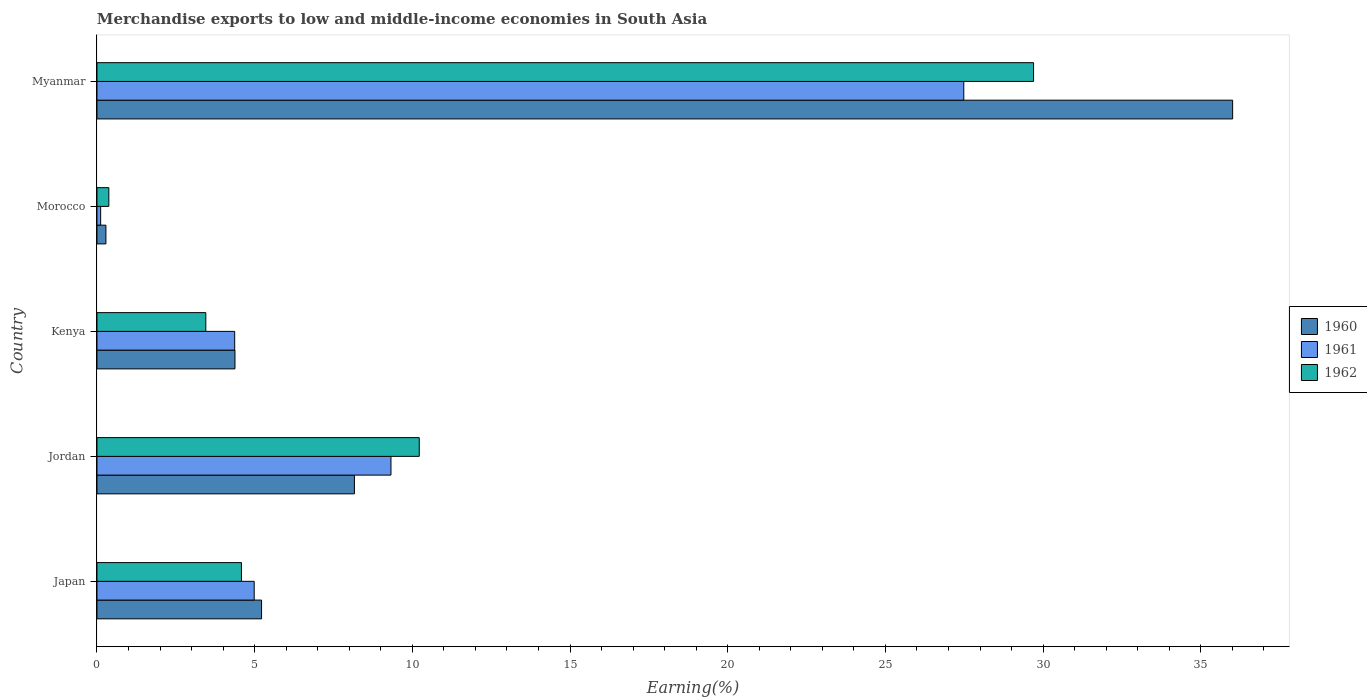How many different coloured bars are there?
Offer a very short reply. 3. How many groups of bars are there?
Ensure brevity in your answer.  5. Are the number of bars per tick equal to the number of legend labels?
Ensure brevity in your answer.  Yes. Are the number of bars on each tick of the Y-axis equal?
Your answer should be compact. Yes. How many bars are there on the 4th tick from the top?
Offer a terse response. 3. What is the label of the 3rd group of bars from the top?
Offer a terse response. Kenya. In how many cases, is the number of bars for a given country not equal to the number of legend labels?
Your answer should be compact. 0. What is the percentage of amount earned from merchandise exports in 1961 in Kenya?
Ensure brevity in your answer.  4.37. Across all countries, what is the maximum percentage of amount earned from merchandise exports in 1961?
Offer a very short reply. 27.48. Across all countries, what is the minimum percentage of amount earned from merchandise exports in 1961?
Give a very brief answer. 0.12. In which country was the percentage of amount earned from merchandise exports in 1962 maximum?
Provide a succinct answer. Myanmar. In which country was the percentage of amount earned from merchandise exports in 1962 minimum?
Provide a succinct answer. Morocco. What is the total percentage of amount earned from merchandise exports in 1960 in the graph?
Keep it short and to the point. 54.05. What is the difference between the percentage of amount earned from merchandise exports in 1962 in Jordan and that in Morocco?
Make the answer very short. 9.84. What is the difference between the percentage of amount earned from merchandise exports in 1962 in Jordan and the percentage of amount earned from merchandise exports in 1961 in Japan?
Your answer should be compact. 5.23. What is the average percentage of amount earned from merchandise exports in 1962 per country?
Offer a very short reply. 9.66. What is the difference between the percentage of amount earned from merchandise exports in 1961 and percentage of amount earned from merchandise exports in 1962 in Japan?
Provide a short and direct response. 0.4. What is the ratio of the percentage of amount earned from merchandise exports in 1962 in Japan to that in Morocco?
Keep it short and to the point. 12.17. Is the percentage of amount earned from merchandise exports in 1962 in Japan less than that in Myanmar?
Offer a terse response. Yes. Is the difference between the percentage of amount earned from merchandise exports in 1961 in Jordan and Myanmar greater than the difference between the percentage of amount earned from merchandise exports in 1962 in Jordan and Myanmar?
Your answer should be very brief. Yes. What is the difference between the highest and the second highest percentage of amount earned from merchandise exports in 1960?
Make the answer very short. 27.85. What is the difference between the highest and the lowest percentage of amount earned from merchandise exports in 1962?
Offer a terse response. 29.32. How many bars are there?
Give a very brief answer. 15. What is the difference between two consecutive major ticks on the X-axis?
Your response must be concise. 5. Does the graph contain grids?
Ensure brevity in your answer.  No. How many legend labels are there?
Ensure brevity in your answer.  3. How are the legend labels stacked?
Ensure brevity in your answer.  Vertical. What is the title of the graph?
Your response must be concise. Merchandise exports to low and middle-income economies in South Asia. What is the label or title of the X-axis?
Keep it short and to the point. Earning(%). What is the label or title of the Y-axis?
Your response must be concise. Country. What is the Earning(%) of 1960 in Japan?
Your answer should be compact. 5.22. What is the Earning(%) in 1961 in Japan?
Provide a short and direct response. 4.99. What is the Earning(%) of 1962 in Japan?
Make the answer very short. 4.58. What is the Earning(%) in 1960 in Jordan?
Offer a very short reply. 8.16. What is the Earning(%) of 1961 in Jordan?
Offer a very short reply. 9.32. What is the Earning(%) of 1962 in Jordan?
Ensure brevity in your answer.  10.22. What is the Earning(%) of 1960 in Kenya?
Offer a terse response. 4.38. What is the Earning(%) in 1961 in Kenya?
Keep it short and to the point. 4.37. What is the Earning(%) of 1962 in Kenya?
Your answer should be compact. 3.45. What is the Earning(%) in 1960 in Morocco?
Provide a short and direct response. 0.28. What is the Earning(%) in 1961 in Morocco?
Offer a very short reply. 0.12. What is the Earning(%) in 1962 in Morocco?
Your answer should be compact. 0.38. What is the Earning(%) of 1960 in Myanmar?
Ensure brevity in your answer.  36.01. What is the Earning(%) of 1961 in Myanmar?
Give a very brief answer. 27.48. What is the Earning(%) in 1962 in Myanmar?
Provide a short and direct response. 29.7. Across all countries, what is the maximum Earning(%) in 1960?
Provide a short and direct response. 36.01. Across all countries, what is the maximum Earning(%) of 1961?
Your answer should be compact. 27.48. Across all countries, what is the maximum Earning(%) in 1962?
Make the answer very short. 29.7. Across all countries, what is the minimum Earning(%) in 1960?
Offer a very short reply. 0.28. Across all countries, what is the minimum Earning(%) in 1961?
Your answer should be compact. 0.12. Across all countries, what is the minimum Earning(%) of 1962?
Offer a very short reply. 0.38. What is the total Earning(%) in 1960 in the graph?
Offer a terse response. 54.05. What is the total Earning(%) in 1961 in the graph?
Your response must be concise. 46.28. What is the total Earning(%) in 1962 in the graph?
Make the answer very short. 48.32. What is the difference between the Earning(%) of 1960 in Japan and that in Jordan?
Your answer should be compact. -2.94. What is the difference between the Earning(%) in 1961 in Japan and that in Jordan?
Offer a terse response. -4.34. What is the difference between the Earning(%) of 1962 in Japan and that in Jordan?
Offer a very short reply. -5.64. What is the difference between the Earning(%) of 1960 in Japan and that in Kenya?
Your response must be concise. 0.84. What is the difference between the Earning(%) of 1961 in Japan and that in Kenya?
Your response must be concise. 0.62. What is the difference between the Earning(%) of 1962 in Japan and that in Kenya?
Keep it short and to the point. 1.13. What is the difference between the Earning(%) of 1960 in Japan and that in Morocco?
Provide a short and direct response. 4.93. What is the difference between the Earning(%) of 1961 in Japan and that in Morocco?
Your answer should be very brief. 4.87. What is the difference between the Earning(%) of 1962 in Japan and that in Morocco?
Your answer should be compact. 4.2. What is the difference between the Earning(%) in 1960 in Japan and that in Myanmar?
Your answer should be very brief. -30.79. What is the difference between the Earning(%) of 1961 in Japan and that in Myanmar?
Ensure brevity in your answer.  -22.5. What is the difference between the Earning(%) of 1962 in Japan and that in Myanmar?
Your answer should be compact. -25.12. What is the difference between the Earning(%) of 1960 in Jordan and that in Kenya?
Your response must be concise. 3.79. What is the difference between the Earning(%) in 1961 in Jordan and that in Kenya?
Provide a succinct answer. 4.96. What is the difference between the Earning(%) in 1962 in Jordan and that in Kenya?
Your answer should be compact. 6.77. What is the difference between the Earning(%) of 1960 in Jordan and that in Morocco?
Offer a terse response. 7.88. What is the difference between the Earning(%) in 1961 in Jordan and that in Morocco?
Ensure brevity in your answer.  9.21. What is the difference between the Earning(%) of 1962 in Jordan and that in Morocco?
Your answer should be very brief. 9.84. What is the difference between the Earning(%) in 1960 in Jordan and that in Myanmar?
Offer a very short reply. -27.85. What is the difference between the Earning(%) of 1961 in Jordan and that in Myanmar?
Offer a terse response. -18.16. What is the difference between the Earning(%) in 1962 in Jordan and that in Myanmar?
Give a very brief answer. -19.48. What is the difference between the Earning(%) in 1960 in Kenya and that in Morocco?
Offer a very short reply. 4.09. What is the difference between the Earning(%) in 1961 in Kenya and that in Morocco?
Provide a short and direct response. 4.25. What is the difference between the Earning(%) in 1962 in Kenya and that in Morocco?
Your answer should be very brief. 3.07. What is the difference between the Earning(%) of 1960 in Kenya and that in Myanmar?
Your response must be concise. -31.63. What is the difference between the Earning(%) in 1961 in Kenya and that in Myanmar?
Offer a terse response. -23.12. What is the difference between the Earning(%) of 1962 in Kenya and that in Myanmar?
Provide a short and direct response. -26.25. What is the difference between the Earning(%) of 1960 in Morocco and that in Myanmar?
Ensure brevity in your answer.  -35.73. What is the difference between the Earning(%) of 1961 in Morocco and that in Myanmar?
Your response must be concise. -27.37. What is the difference between the Earning(%) in 1962 in Morocco and that in Myanmar?
Provide a succinct answer. -29.32. What is the difference between the Earning(%) in 1960 in Japan and the Earning(%) in 1961 in Jordan?
Keep it short and to the point. -4.1. What is the difference between the Earning(%) of 1960 in Japan and the Earning(%) of 1962 in Jordan?
Offer a very short reply. -5. What is the difference between the Earning(%) in 1961 in Japan and the Earning(%) in 1962 in Jordan?
Ensure brevity in your answer.  -5.23. What is the difference between the Earning(%) in 1960 in Japan and the Earning(%) in 1961 in Kenya?
Give a very brief answer. 0.85. What is the difference between the Earning(%) in 1960 in Japan and the Earning(%) in 1962 in Kenya?
Your answer should be very brief. 1.77. What is the difference between the Earning(%) of 1961 in Japan and the Earning(%) of 1962 in Kenya?
Offer a very short reply. 1.53. What is the difference between the Earning(%) in 1960 in Japan and the Earning(%) in 1961 in Morocco?
Give a very brief answer. 5.1. What is the difference between the Earning(%) in 1960 in Japan and the Earning(%) in 1962 in Morocco?
Keep it short and to the point. 4.84. What is the difference between the Earning(%) of 1961 in Japan and the Earning(%) of 1962 in Morocco?
Ensure brevity in your answer.  4.61. What is the difference between the Earning(%) in 1960 in Japan and the Earning(%) in 1961 in Myanmar?
Provide a succinct answer. -22.27. What is the difference between the Earning(%) of 1960 in Japan and the Earning(%) of 1962 in Myanmar?
Ensure brevity in your answer.  -24.48. What is the difference between the Earning(%) in 1961 in Japan and the Earning(%) in 1962 in Myanmar?
Keep it short and to the point. -24.71. What is the difference between the Earning(%) of 1960 in Jordan and the Earning(%) of 1961 in Kenya?
Offer a very short reply. 3.8. What is the difference between the Earning(%) of 1960 in Jordan and the Earning(%) of 1962 in Kenya?
Give a very brief answer. 4.71. What is the difference between the Earning(%) of 1961 in Jordan and the Earning(%) of 1962 in Kenya?
Your answer should be compact. 5.87. What is the difference between the Earning(%) in 1960 in Jordan and the Earning(%) in 1961 in Morocco?
Make the answer very short. 8.05. What is the difference between the Earning(%) of 1960 in Jordan and the Earning(%) of 1962 in Morocco?
Give a very brief answer. 7.79. What is the difference between the Earning(%) of 1961 in Jordan and the Earning(%) of 1962 in Morocco?
Your response must be concise. 8.95. What is the difference between the Earning(%) in 1960 in Jordan and the Earning(%) in 1961 in Myanmar?
Provide a succinct answer. -19.32. What is the difference between the Earning(%) of 1960 in Jordan and the Earning(%) of 1962 in Myanmar?
Provide a succinct answer. -21.53. What is the difference between the Earning(%) in 1961 in Jordan and the Earning(%) in 1962 in Myanmar?
Make the answer very short. -20.38. What is the difference between the Earning(%) in 1960 in Kenya and the Earning(%) in 1961 in Morocco?
Provide a succinct answer. 4.26. What is the difference between the Earning(%) in 1960 in Kenya and the Earning(%) in 1962 in Morocco?
Provide a short and direct response. 4. What is the difference between the Earning(%) of 1961 in Kenya and the Earning(%) of 1962 in Morocco?
Your answer should be very brief. 3.99. What is the difference between the Earning(%) of 1960 in Kenya and the Earning(%) of 1961 in Myanmar?
Your response must be concise. -23.11. What is the difference between the Earning(%) in 1960 in Kenya and the Earning(%) in 1962 in Myanmar?
Give a very brief answer. -25.32. What is the difference between the Earning(%) of 1961 in Kenya and the Earning(%) of 1962 in Myanmar?
Ensure brevity in your answer.  -25.33. What is the difference between the Earning(%) of 1960 in Morocco and the Earning(%) of 1961 in Myanmar?
Provide a succinct answer. -27.2. What is the difference between the Earning(%) in 1960 in Morocco and the Earning(%) in 1962 in Myanmar?
Ensure brevity in your answer.  -29.41. What is the difference between the Earning(%) of 1961 in Morocco and the Earning(%) of 1962 in Myanmar?
Keep it short and to the point. -29.58. What is the average Earning(%) of 1960 per country?
Your answer should be very brief. 10.81. What is the average Earning(%) in 1961 per country?
Make the answer very short. 9.26. What is the average Earning(%) in 1962 per country?
Make the answer very short. 9.66. What is the difference between the Earning(%) of 1960 and Earning(%) of 1961 in Japan?
Make the answer very short. 0.23. What is the difference between the Earning(%) of 1960 and Earning(%) of 1962 in Japan?
Keep it short and to the point. 0.64. What is the difference between the Earning(%) in 1961 and Earning(%) in 1962 in Japan?
Make the answer very short. 0.4. What is the difference between the Earning(%) of 1960 and Earning(%) of 1961 in Jordan?
Give a very brief answer. -1.16. What is the difference between the Earning(%) in 1960 and Earning(%) in 1962 in Jordan?
Make the answer very short. -2.06. What is the difference between the Earning(%) in 1961 and Earning(%) in 1962 in Jordan?
Your response must be concise. -0.9. What is the difference between the Earning(%) of 1960 and Earning(%) of 1961 in Kenya?
Your answer should be compact. 0.01. What is the difference between the Earning(%) in 1960 and Earning(%) in 1962 in Kenya?
Ensure brevity in your answer.  0.92. What is the difference between the Earning(%) in 1961 and Earning(%) in 1962 in Kenya?
Your response must be concise. 0.92. What is the difference between the Earning(%) in 1960 and Earning(%) in 1961 in Morocco?
Your answer should be very brief. 0.17. What is the difference between the Earning(%) in 1960 and Earning(%) in 1962 in Morocco?
Your answer should be very brief. -0.09. What is the difference between the Earning(%) of 1961 and Earning(%) of 1962 in Morocco?
Offer a very short reply. -0.26. What is the difference between the Earning(%) in 1960 and Earning(%) in 1961 in Myanmar?
Your response must be concise. 8.52. What is the difference between the Earning(%) of 1960 and Earning(%) of 1962 in Myanmar?
Keep it short and to the point. 6.31. What is the difference between the Earning(%) in 1961 and Earning(%) in 1962 in Myanmar?
Provide a succinct answer. -2.21. What is the ratio of the Earning(%) in 1960 in Japan to that in Jordan?
Offer a very short reply. 0.64. What is the ratio of the Earning(%) in 1961 in Japan to that in Jordan?
Provide a short and direct response. 0.53. What is the ratio of the Earning(%) of 1962 in Japan to that in Jordan?
Make the answer very short. 0.45. What is the ratio of the Earning(%) in 1960 in Japan to that in Kenya?
Ensure brevity in your answer.  1.19. What is the ratio of the Earning(%) in 1961 in Japan to that in Kenya?
Keep it short and to the point. 1.14. What is the ratio of the Earning(%) in 1962 in Japan to that in Kenya?
Your answer should be very brief. 1.33. What is the ratio of the Earning(%) in 1960 in Japan to that in Morocco?
Your answer should be compact. 18.39. What is the ratio of the Earning(%) of 1961 in Japan to that in Morocco?
Offer a very short reply. 42.61. What is the ratio of the Earning(%) of 1962 in Japan to that in Morocco?
Your answer should be compact. 12.17. What is the ratio of the Earning(%) in 1960 in Japan to that in Myanmar?
Ensure brevity in your answer.  0.14. What is the ratio of the Earning(%) in 1961 in Japan to that in Myanmar?
Make the answer very short. 0.18. What is the ratio of the Earning(%) of 1962 in Japan to that in Myanmar?
Give a very brief answer. 0.15. What is the ratio of the Earning(%) in 1960 in Jordan to that in Kenya?
Keep it short and to the point. 1.87. What is the ratio of the Earning(%) in 1961 in Jordan to that in Kenya?
Keep it short and to the point. 2.13. What is the ratio of the Earning(%) in 1962 in Jordan to that in Kenya?
Your answer should be compact. 2.96. What is the ratio of the Earning(%) of 1960 in Jordan to that in Morocco?
Give a very brief answer. 28.77. What is the ratio of the Earning(%) of 1961 in Jordan to that in Morocco?
Your response must be concise. 79.68. What is the ratio of the Earning(%) in 1962 in Jordan to that in Morocco?
Offer a terse response. 27.14. What is the ratio of the Earning(%) of 1960 in Jordan to that in Myanmar?
Offer a very short reply. 0.23. What is the ratio of the Earning(%) in 1961 in Jordan to that in Myanmar?
Ensure brevity in your answer.  0.34. What is the ratio of the Earning(%) of 1962 in Jordan to that in Myanmar?
Offer a terse response. 0.34. What is the ratio of the Earning(%) of 1960 in Kenya to that in Morocco?
Provide a succinct answer. 15.42. What is the ratio of the Earning(%) of 1961 in Kenya to that in Morocco?
Offer a terse response. 37.33. What is the ratio of the Earning(%) of 1962 in Kenya to that in Morocco?
Ensure brevity in your answer.  9.17. What is the ratio of the Earning(%) of 1960 in Kenya to that in Myanmar?
Your answer should be compact. 0.12. What is the ratio of the Earning(%) of 1961 in Kenya to that in Myanmar?
Your answer should be very brief. 0.16. What is the ratio of the Earning(%) of 1962 in Kenya to that in Myanmar?
Offer a terse response. 0.12. What is the ratio of the Earning(%) in 1960 in Morocco to that in Myanmar?
Ensure brevity in your answer.  0.01. What is the ratio of the Earning(%) in 1961 in Morocco to that in Myanmar?
Your answer should be compact. 0. What is the ratio of the Earning(%) of 1962 in Morocco to that in Myanmar?
Offer a terse response. 0.01. What is the difference between the highest and the second highest Earning(%) of 1960?
Offer a terse response. 27.85. What is the difference between the highest and the second highest Earning(%) of 1961?
Provide a succinct answer. 18.16. What is the difference between the highest and the second highest Earning(%) of 1962?
Your answer should be compact. 19.48. What is the difference between the highest and the lowest Earning(%) in 1960?
Offer a very short reply. 35.73. What is the difference between the highest and the lowest Earning(%) of 1961?
Make the answer very short. 27.37. What is the difference between the highest and the lowest Earning(%) of 1962?
Give a very brief answer. 29.32. 